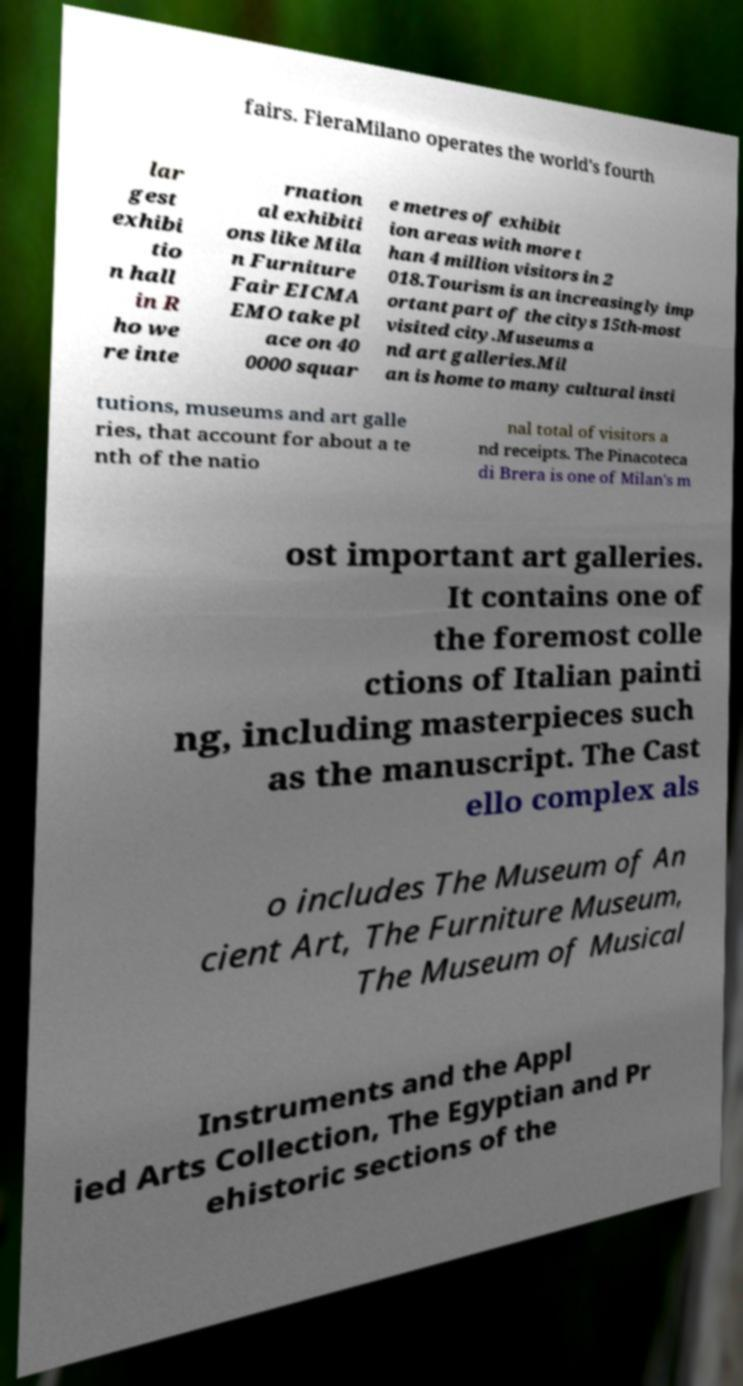Could you extract and type out the text from this image? fairs. FieraMilano operates the world's fourth lar gest exhibi tio n hall in R ho we re inte rnation al exhibiti ons like Mila n Furniture Fair EICMA EMO take pl ace on 40 0000 squar e metres of exhibit ion areas with more t han 4 million visitors in 2 018.Tourism is an increasingly imp ortant part of the citys 15th-most visited city.Museums a nd art galleries.Mil an is home to many cultural insti tutions, museums and art galle ries, that account for about a te nth of the natio nal total of visitors a nd receipts. The Pinacoteca di Brera is one of Milan's m ost important art galleries. It contains one of the foremost colle ctions of Italian painti ng, including masterpieces such as the manuscript. The Cast ello complex als o includes The Museum of An cient Art, The Furniture Museum, The Museum of Musical Instruments and the Appl ied Arts Collection, The Egyptian and Pr ehistoric sections of the 